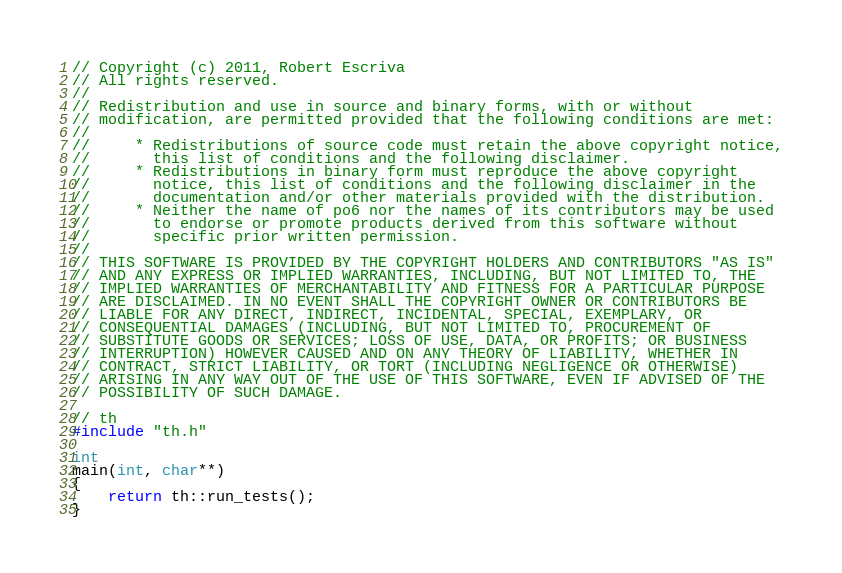<code> <loc_0><loc_0><loc_500><loc_500><_C++_>// Copyright (c) 2011, Robert Escriva
// All rights reserved.
//
// Redistribution and use in source and binary forms, with or without
// modification, are permitted provided that the following conditions are met:
//
//     * Redistributions of source code must retain the above copyright notice,
//       this list of conditions and the following disclaimer.
//     * Redistributions in binary form must reproduce the above copyright
//       notice, this list of conditions and the following disclaimer in the
//       documentation and/or other materials provided with the distribution.
//     * Neither the name of po6 nor the names of its contributors may be used
//       to endorse or promote products derived from this software without
//       specific prior written permission.
//
// THIS SOFTWARE IS PROVIDED BY THE COPYRIGHT HOLDERS AND CONTRIBUTORS "AS IS"
// AND ANY EXPRESS OR IMPLIED WARRANTIES, INCLUDING, BUT NOT LIMITED TO, THE
// IMPLIED WARRANTIES OF MERCHANTABILITY AND FITNESS FOR A PARTICULAR PURPOSE
// ARE DISCLAIMED. IN NO EVENT SHALL THE COPYRIGHT OWNER OR CONTRIBUTORS BE
// LIABLE FOR ANY DIRECT, INDIRECT, INCIDENTAL, SPECIAL, EXEMPLARY, OR
// CONSEQUENTIAL DAMAGES (INCLUDING, BUT NOT LIMITED TO, PROCUREMENT OF
// SUBSTITUTE GOODS OR SERVICES; LOSS OF USE, DATA, OR PROFITS; OR BUSINESS
// INTERRUPTION) HOWEVER CAUSED AND ON ANY THEORY OF LIABILITY, WHETHER IN
// CONTRACT, STRICT LIABILITY, OR TORT (INCLUDING NEGLIGENCE OR OTHERWISE)
// ARISING IN ANY WAY OUT OF THE USE OF THIS SOFTWARE, EVEN IF ADVISED OF THE
// POSSIBILITY OF SUCH DAMAGE.

// th
#include "th.h"

int
main(int, char**)
{
    return th::run_tests();
}
</code> 